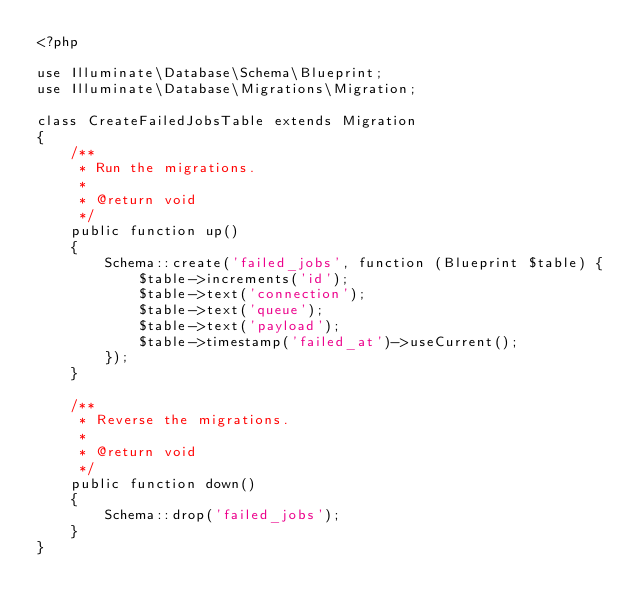Convert code to text. <code><loc_0><loc_0><loc_500><loc_500><_PHP_><?php

use Illuminate\Database\Schema\Blueprint;
use Illuminate\Database\Migrations\Migration;

class CreateFailedJobsTable extends Migration
{
    /**
     * Run the migrations.
     *
     * @return void
     */
    public function up()
    {
        Schema::create('failed_jobs', function (Blueprint $table) {
            $table->increments('id');
            $table->text('connection');
            $table->text('queue');
            $table->text('payload');
            $table->timestamp('failed_at')->useCurrent();
        });
    }

    /**
     * Reverse the migrations.
     *
     * @return void
     */
    public function down()
    {
        Schema::drop('failed_jobs');
    }
}
</code> 